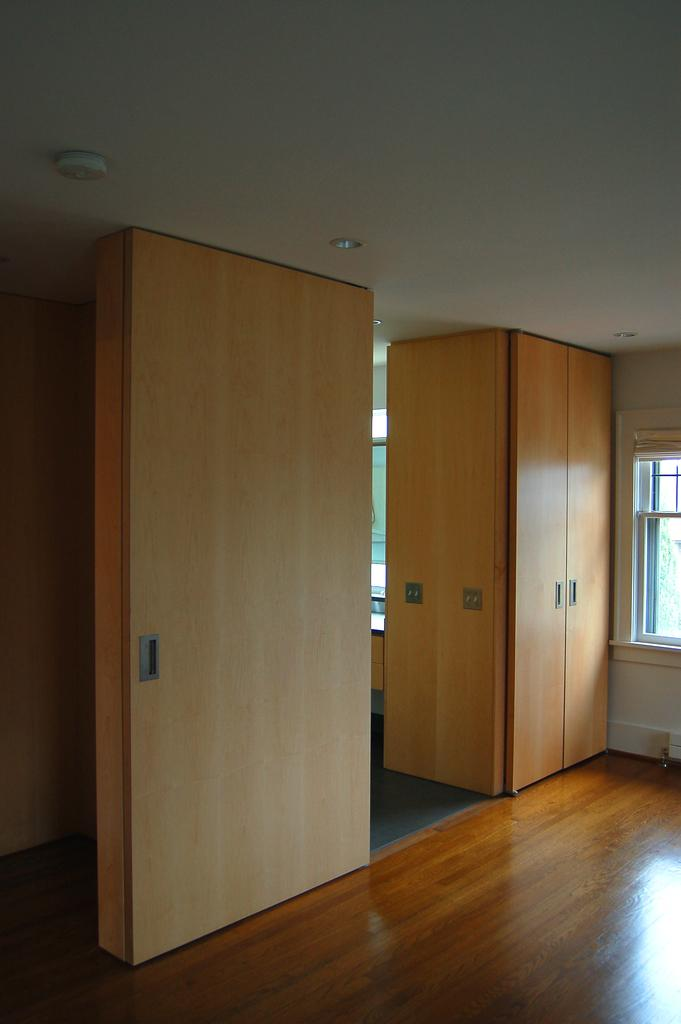What type of flooring is visible in the image? There is a wooden floor in the image. What type of furniture can be seen in the image? There are cupboards in the image. What allows natural light into the room in the image? There are windows in the image. What covers the top of the room in the image? There is a roof in the image. What type of jewel is hanging from the tongue of the person in the image? There is no person or jewel present in the image; it only features a wooden floor, cupboards, windows, and a roof. 